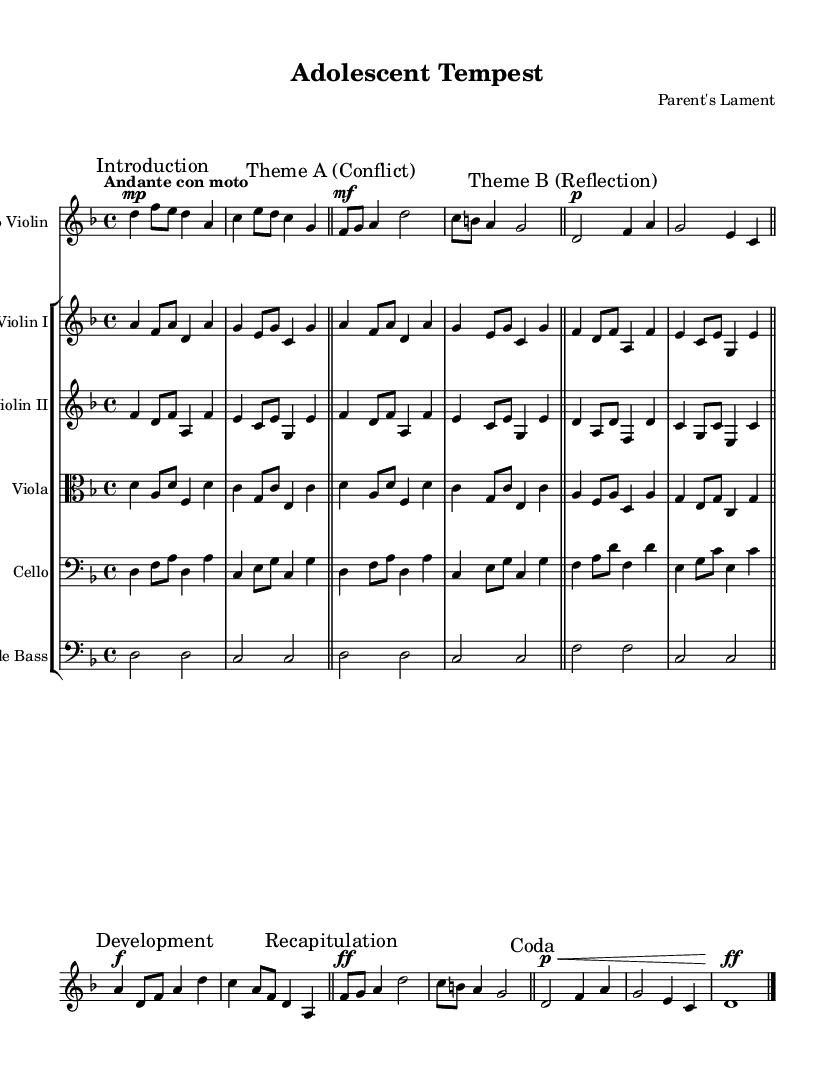What is the key signature of this music? The key signature is indicated by the sharps or flats at the beginning of the staff. In this case, there are no sharps or flats, indicating the piece is in the key of D minor.
Answer: D minor What is the time signature of this piece? The time signature is found at the beginning of the sheet music and is represented as a fraction. Here, it shows "4/4," meaning there are four beats in each measure, and the quarter note gets one beat.
Answer: 4/4 What is the tempo marking for this piece? The tempo marking is at the beginning of the score, indicating how fast or slow the music should be played. Here, it reads "Andante con moto," suggesting a moderate speed with some movement.
Answer: Andante con moto What is the dynamic marking for the introduction section? The dynamic marking indicates the volume of the music. The introduction section starts with "mp," which means mezzo-piano, or moderately soft.
Answer: mp How many themes are presented in the music? Themes can be identified by sections labeled within the music. The sheet music contains two distinct themes labeled "Theme A" and "Theme B." This gives a total of two themes presented in the piece.
Answer: 2 What characterizes Theme A in terms of emotional expression? Theme A is specifically labeled "Conflict," indicating that it likely expresses a sense of struggle or tension, which is characteristic of the turbulent journey of adolescence.
Answer: Conflict What is the overall mood conveyed by the final sections of the piece? The final section of the piece is labeled "Coda," and it features a dynamic marking of "ff," which indicates a very loud volume. This generally suggests a resolution or culmination of the previous themes, reflecting a climactic emotional journey.
Answer: Resolution 